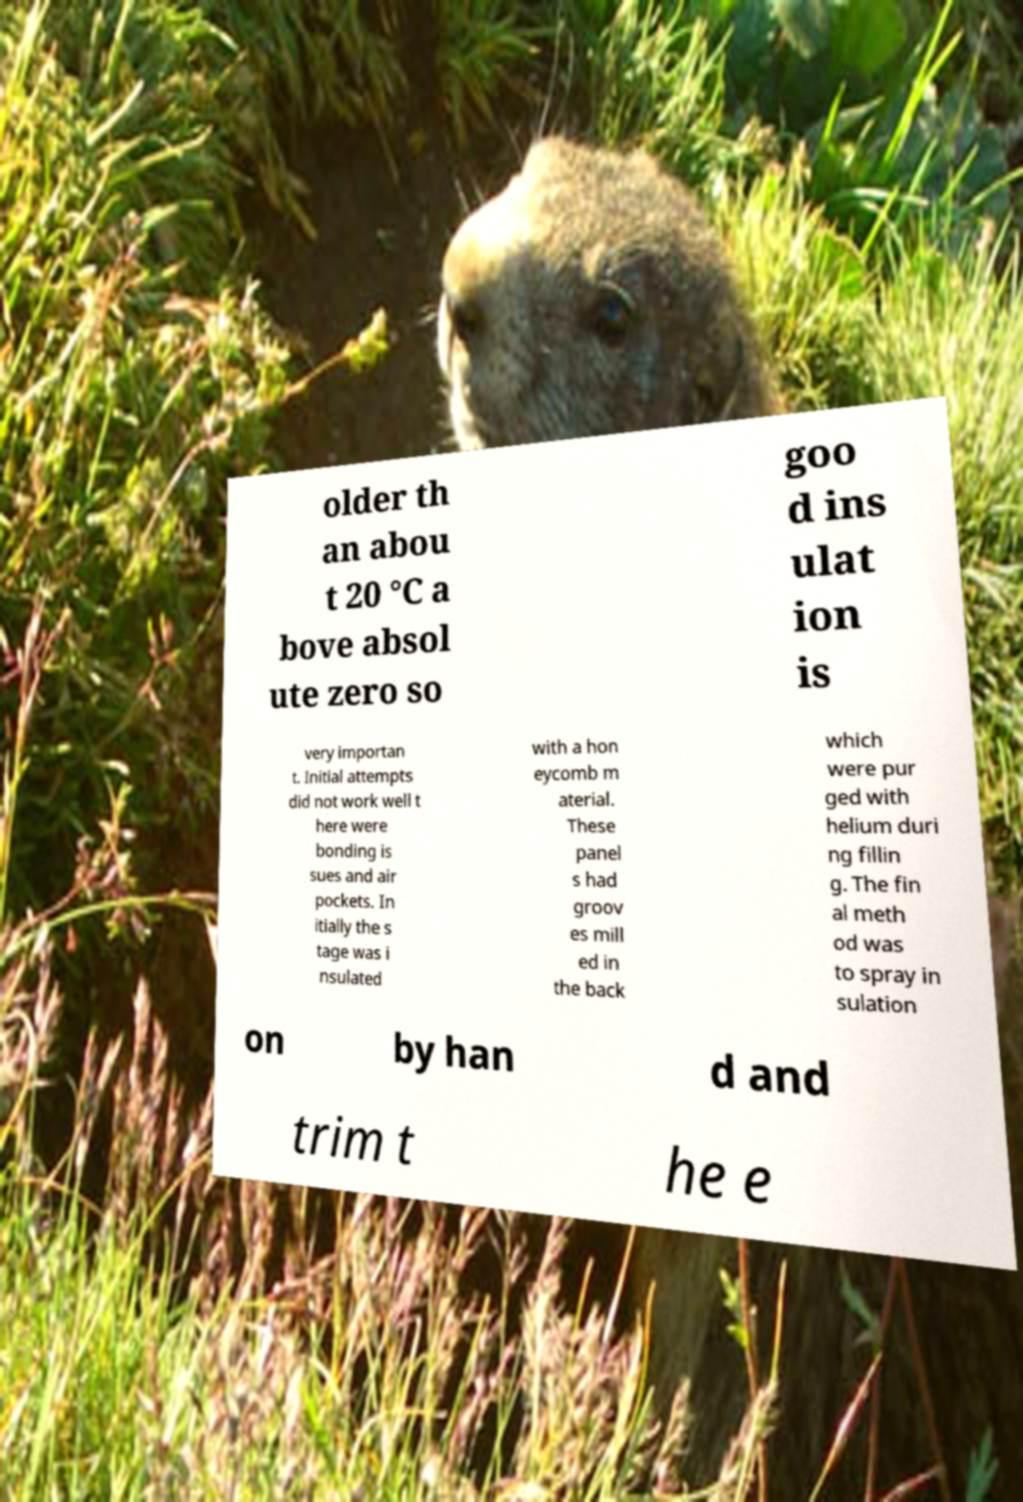Could you extract and type out the text from this image? older th an abou t 20 °C a bove absol ute zero so goo d ins ulat ion is very importan t. Initial attempts did not work well t here were bonding is sues and air pockets. In itially the s tage was i nsulated with a hon eycomb m aterial. These panel s had groov es mill ed in the back which were pur ged with helium duri ng fillin g. The fin al meth od was to spray in sulation on by han d and trim t he e 